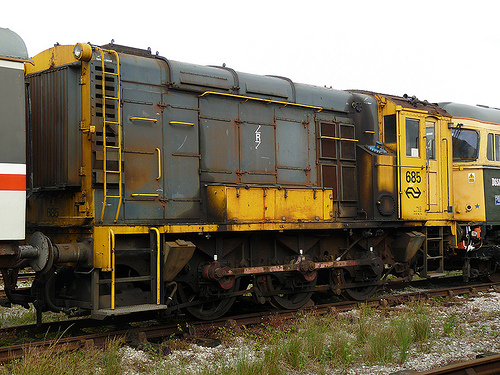What is the gray vehicle? The gray vehicle in the image is a train. 